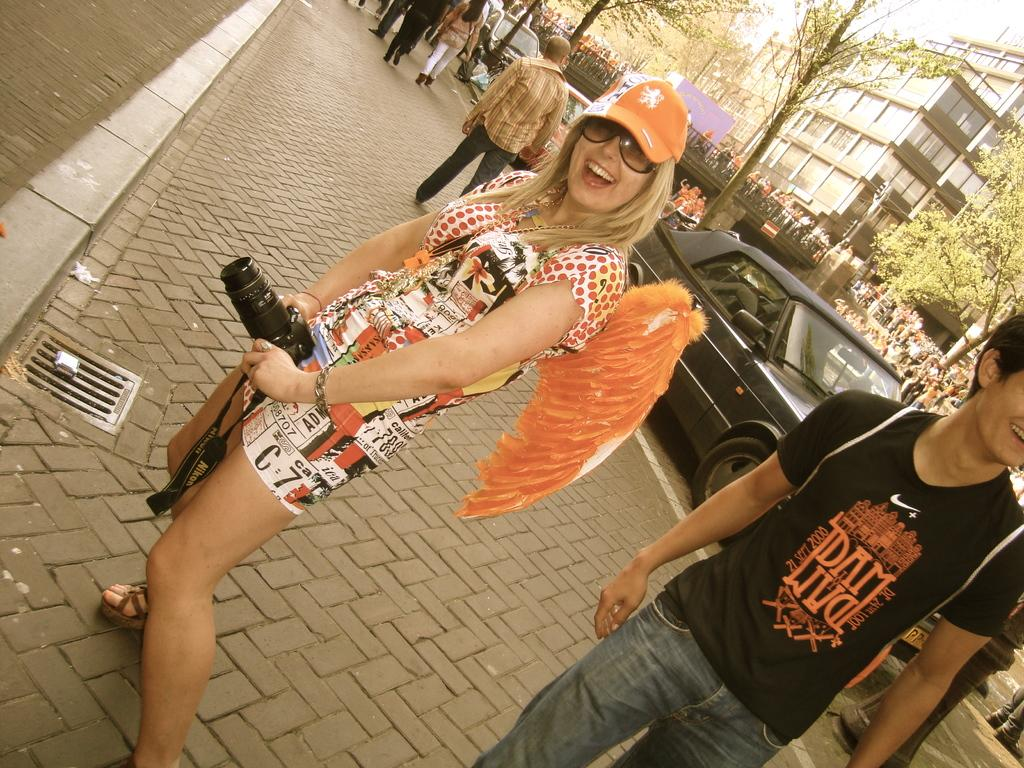Who is the main subject in the image? There is a woman in the image. What is the woman doing in the image? The woman is standing and holding a camera. What can be seen in the background of the image? There are vehicles on the road, trees, a building, and a bridge in the image. What are the people in the image doing? People are walking on a footpath, and there is leg movement visible, indicating people walking. What type of pie is being served at the spy meeting in the image? There is no pie or spy meeting present in the image; it features a woman holding a camera and people walking on a footpath. What type of activity is the woman engaged in with the camera in the image? The woman is holding a camera, but the image does not provide enough information to determine the specific activity she is engaged in. 